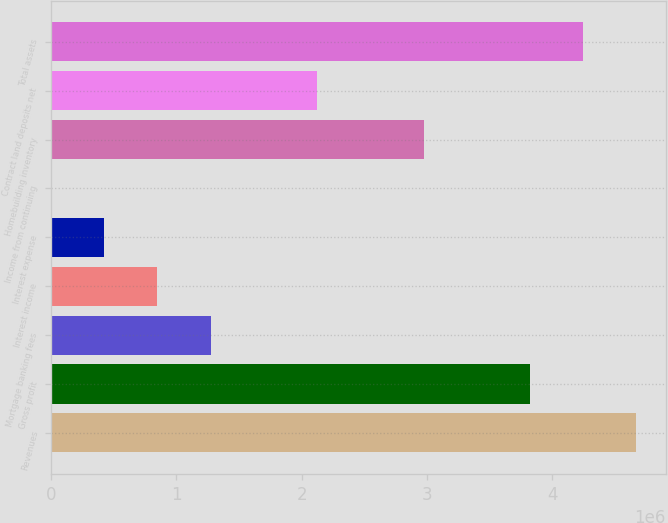Convert chart. <chart><loc_0><loc_0><loc_500><loc_500><bar_chart><fcel>Revenues<fcel>Gross profit<fcel>Mortgage banking fees<fcel>Interest income<fcel>Interest expense<fcel>Income from continuing<fcel>Homebuilding inventory<fcel>Contract land deposits net<fcel>Total assets<nl><fcel>4.67225e+06<fcel>3.82276e+06<fcel>1.2743e+06<fcel>849554<fcel>424810<fcel>66.42<fcel>2.97327e+06<fcel>2.12378e+06<fcel>4.2475e+06<nl></chart> 